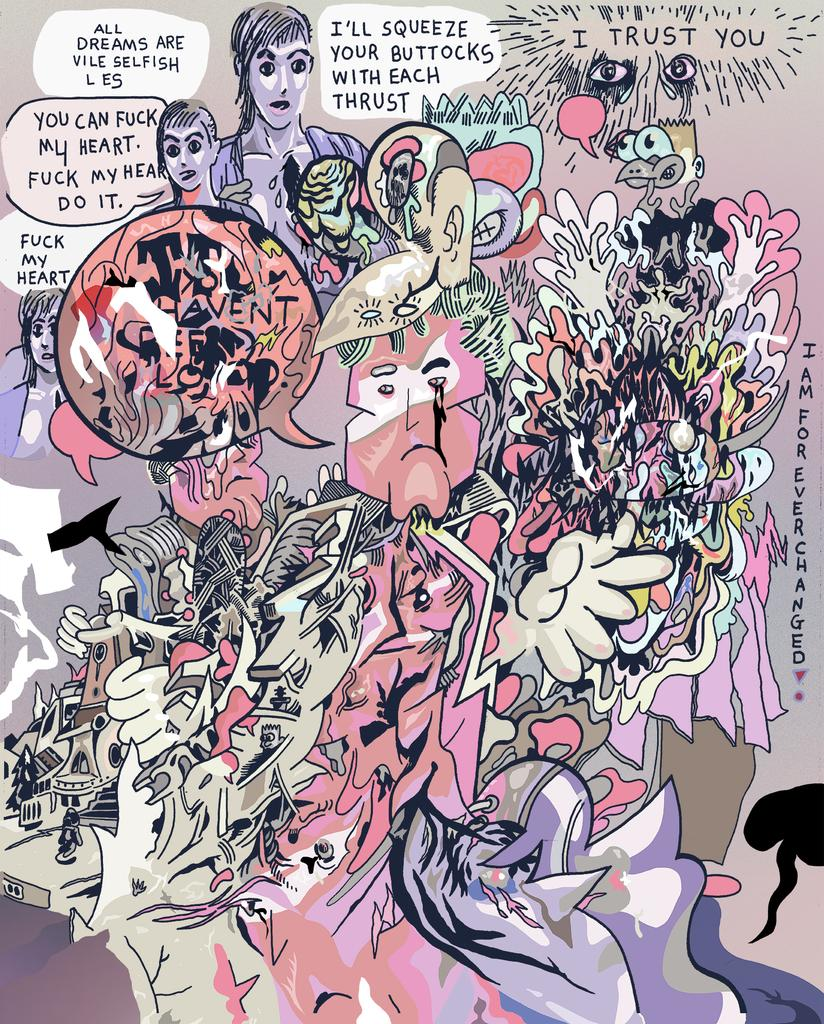What style is the image presented in? The image is a cartoon. What type of magic spell is being cast in the image? There is no magic spell or any indication of magic in the image, as it is a cartoon and not a depiction of a magical scene. 